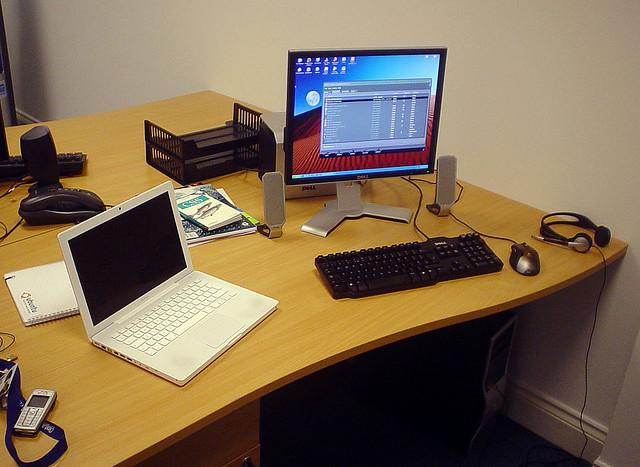What are the two standing rectangular devices? Please explain your reasoning. speakers. There are speakers by the laptop. 